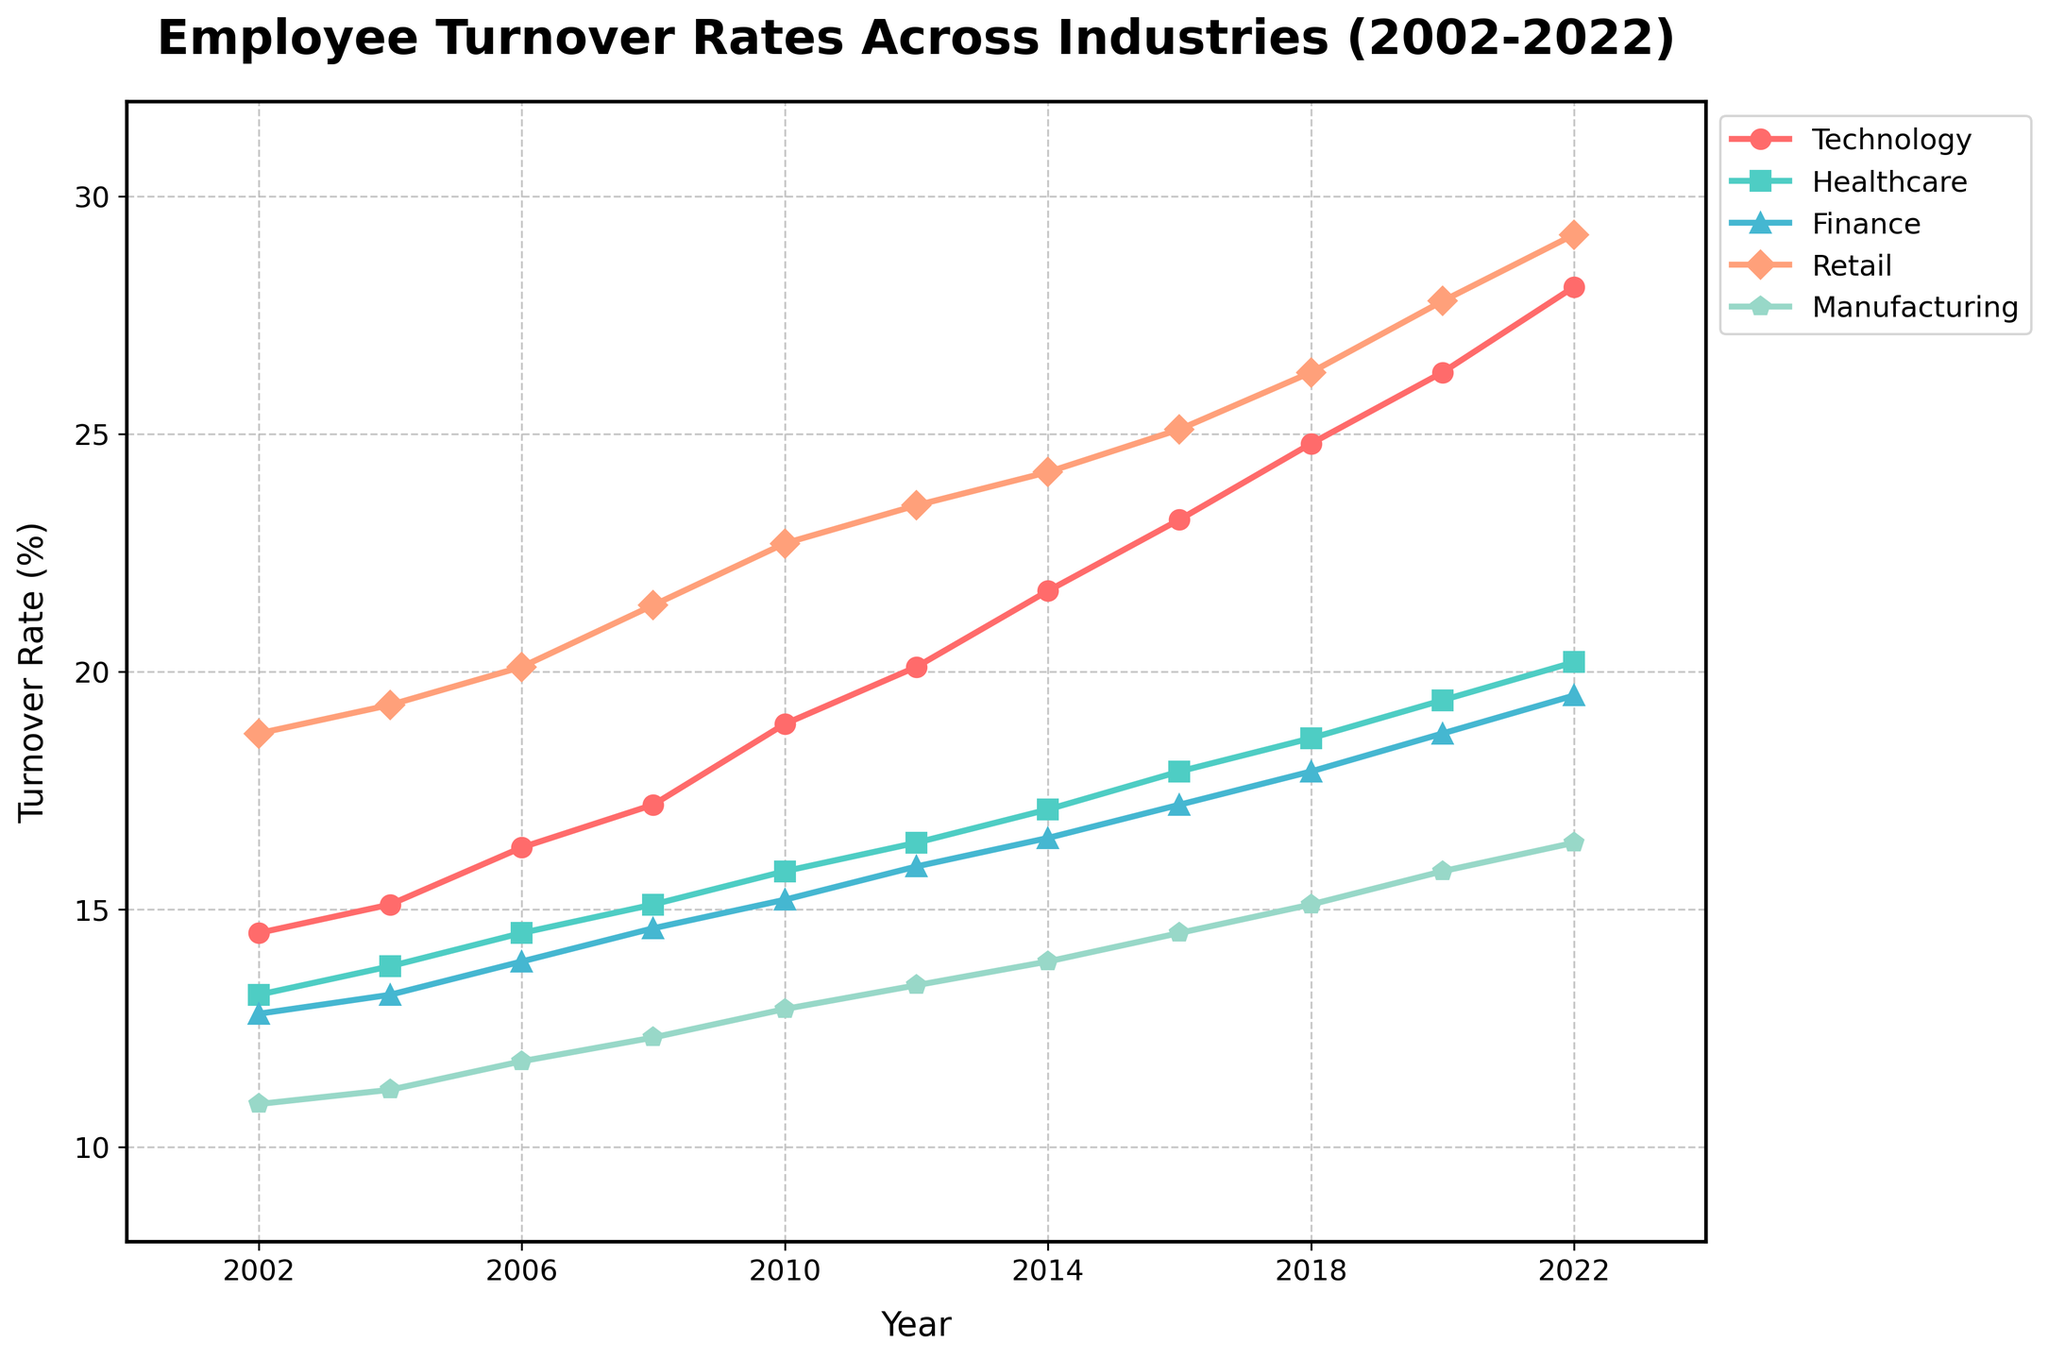What industry shows the highest turnover rate in 2022? By looking at the end of the lines in 2022, the Retail industry has the highest turnover rate among the plotted industries.
Answer: Retail How has the turnover rate in the Technology industry changed from 2002 to 2022? To determine the change, subtract the 2002 value from the 2022 value. The turnover rate in Technology increased from 14.5% in 2002 to 28.1% in 2022, a difference of 13.6%.
Answer: Increased by 13.6% Which two industries have converging turnover rates over the time period? By visually inspecting the trends, the Healthcare and Finance industries have turnover rates that are relatively close throughout the years, starting with similar rates and showing parallel increases.
Answer: Healthcare and Finance Which industry had the smallest turnover rate increase from 2002 to 2022? Calculate the difference between the turnover rates of each industry in 2002 and 2022. The Manufacturing industry had the smallest increase, going from 10.9% in 2002 to 16.4% in 2022, an increase of 5.5%.
Answer: Manufacturing In what year did the Retail industry exceed a 20% turnover rate? By following the line for the Retail industry, it is clear that the turnover rate exceeds 20% in the year 2008.
Answer: 2008 What is the average turnover rate for the Healthcare industry from 2010 to 2020? Sum the Healthcare industry's turnover rates from 2010 (15.8), 2012 (16.4), 2014 (17.1), 2016 (17.9), 2018 (18.6), and 2020 (19.4), then divide by the number of years: (15.8 + 16.4 + 17.1 + 17.9 + 18.6 + 19.4) / 6 = 17.53%.
Answer: 17.53% Is there any year where the turnover rate in Finance is equal to or higher than in Healthcare? By comparing the lines for Finance and Healthcare, there is no year where the Finance industry turnover rate is equal to or higher than that of Healthcare.
Answer: No Which industry had the steepest increase in turnover rate between 2010 and 2014? Calculate the increase for each industry from 2010 to 2014: Technology (21.7 - 18.9 = 2.8), Healthcare (17.1 - 15.8 = 1.3), Finance (16.5 - 15.2 = 1.3), Retail (24.2 - 22.7 = 1.5), Manufacturing (13.9 - 12.9 = 1.0). The Technology industry had the steepest increase of 2.8 percentage points.
Answer: Technology 